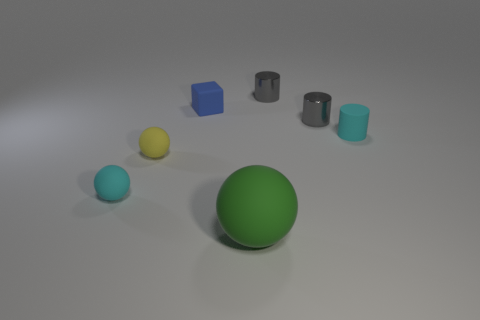Add 1 shiny cylinders. How many objects exist? 8 Subtract all blocks. How many objects are left? 6 Subtract 0 blue balls. How many objects are left? 7 Subtract all tiny blue rubber objects. Subtract all spheres. How many objects are left? 3 Add 7 matte balls. How many matte balls are left? 10 Add 4 large yellow blocks. How many large yellow blocks exist? 4 